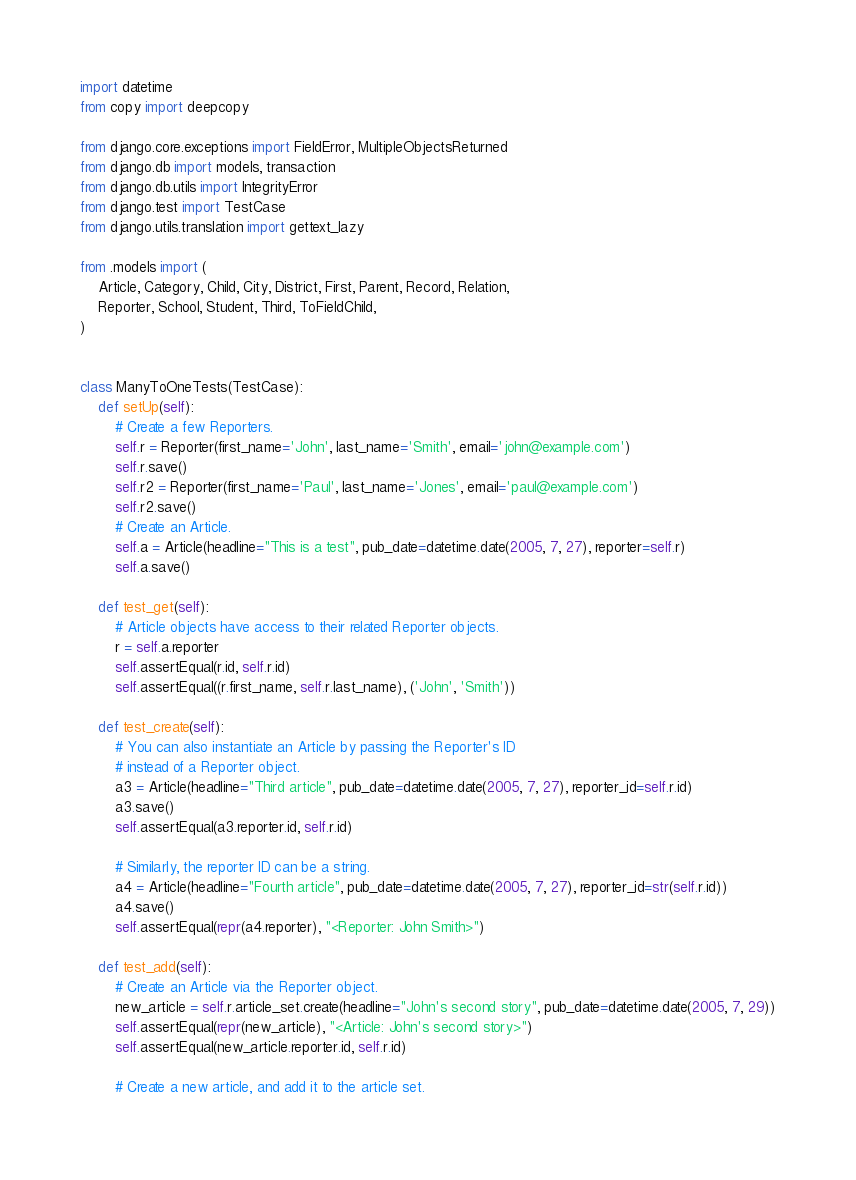Convert code to text. <code><loc_0><loc_0><loc_500><loc_500><_Python_>import datetime
from copy import deepcopy

from django.core.exceptions import FieldError, MultipleObjectsReturned
from django.db import models, transaction
from django.db.utils import IntegrityError
from django.test import TestCase
from django.utils.translation import gettext_lazy

from .models import (
    Article, Category, Child, City, District, First, Parent, Record, Relation,
    Reporter, School, Student, Third, ToFieldChild,
)


class ManyToOneTests(TestCase):
    def setUp(self):
        # Create a few Reporters.
        self.r = Reporter(first_name='John', last_name='Smith', email='john@example.com')
        self.r.save()
        self.r2 = Reporter(first_name='Paul', last_name='Jones', email='paul@example.com')
        self.r2.save()
        # Create an Article.
        self.a = Article(headline="This is a test", pub_date=datetime.date(2005, 7, 27), reporter=self.r)
        self.a.save()

    def test_get(self):
        # Article objects have access to their related Reporter objects.
        r = self.a.reporter
        self.assertEqual(r.id, self.r.id)
        self.assertEqual((r.first_name, self.r.last_name), ('John', 'Smith'))

    def test_create(self):
        # You can also instantiate an Article by passing the Reporter's ID
        # instead of a Reporter object.
        a3 = Article(headline="Third article", pub_date=datetime.date(2005, 7, 27), reporter_id=self.r.id)
        a3.save()
        self.assertEqual(a3.reporter.id, self.r.id)

        # Similarly, the reporter ID can be a string.
        a4 = Article(headline="Fourth article", pub_date=datetime.date(2005, 7, 27), reporter_id=str(self.r.id))
        a4.save()
        self.assertEqual(repr(a4.reporter), "<Reporter: John Smith>")

    def test_add(self):
        # Create an Article via the Reporter object.
        new_article = self.r.article_set.create(headline="John's second story", pub_date=datetime.date(2005, 7, 29))
        self.assertEqual(repr(new_article), "<Article: John's second story>")
        self.assertEqual(new_article.reporter.id, self.r.id)

        # Create a new article, and add it to the article set.</code> 